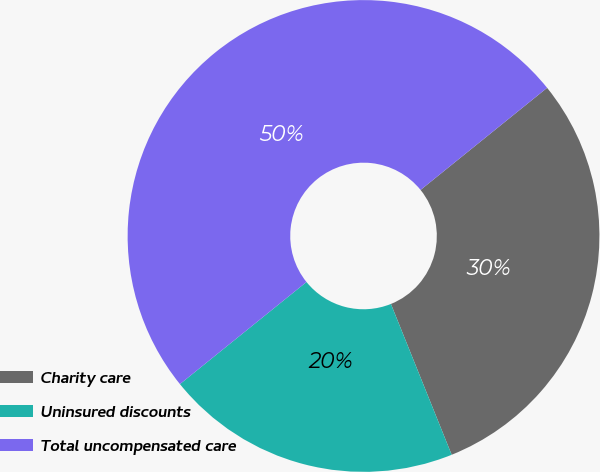Convert chart. <chart><loc_0><loc_0><loc_500><loc_500><pie_chart><fcel>Charity care<fcel>Uninsured discounts<fcel>Total uncompensated care<nl><fcel>29.71%<fcel>20.29%<fcel>50.0%<nl></chart> 